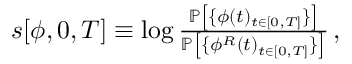<formula> <loc_0><loc_0><loc_500><loc_500>\begin{array} { r } { { s } [ { \phi } , 0 , T ] \equiv \log \frac { \mathbb { P } \left [ \{ \phi ( t ) _ { t \in [ 0 , T ] } \} \right ] } { \mathbb { P } \left [ \{ \phi ^ { R } ( t ) _ { t \in [ 0 , T ] } \} \right ] } \, , } \end{array}</formula> 